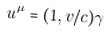Convert formula to latex. <formula><loc_0><loc_0><loc_500><loc_500>u ^ { \mu } = ( 1 , { v } / c ) \gamma</formula> 